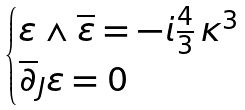<formula> <loc_0><loc_0><loc_500><loc_500>\begin{cases} \varepsilon \wedge \overline { \varepsilon } = - i \frac { 4 } { 3 } \, \kappa ^ { 3 } \\ \overline { \partial } _ { J } \varepsilon = 0 \end{cases}</formula> 